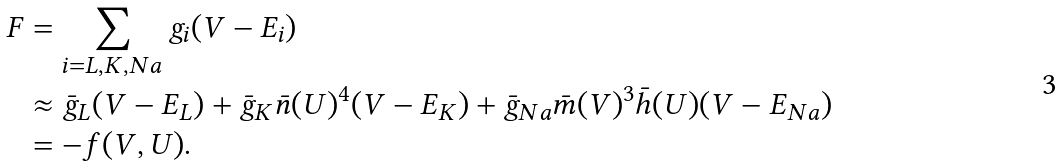Convert formula to latex. <formula><loc_0><loc_0><loc_500><loc_500>F & = \sum _ { i = L , K , N a } g _ { i } ( V - E _ { i } ) \\ & \approx \bar { g } _ { L } ( V - E _ { L } ) + \bar { g } _ { K } \bar { n } ( U ) ^ { 4 } ( V - E _ { K } ) + \bar { g } _ { N a } \bar { m } ( V ) ^ { 3 } \bar { h } ( U ) ( V - E _ { N a } ) \\ & = - f ( V , U ) .</formula> 